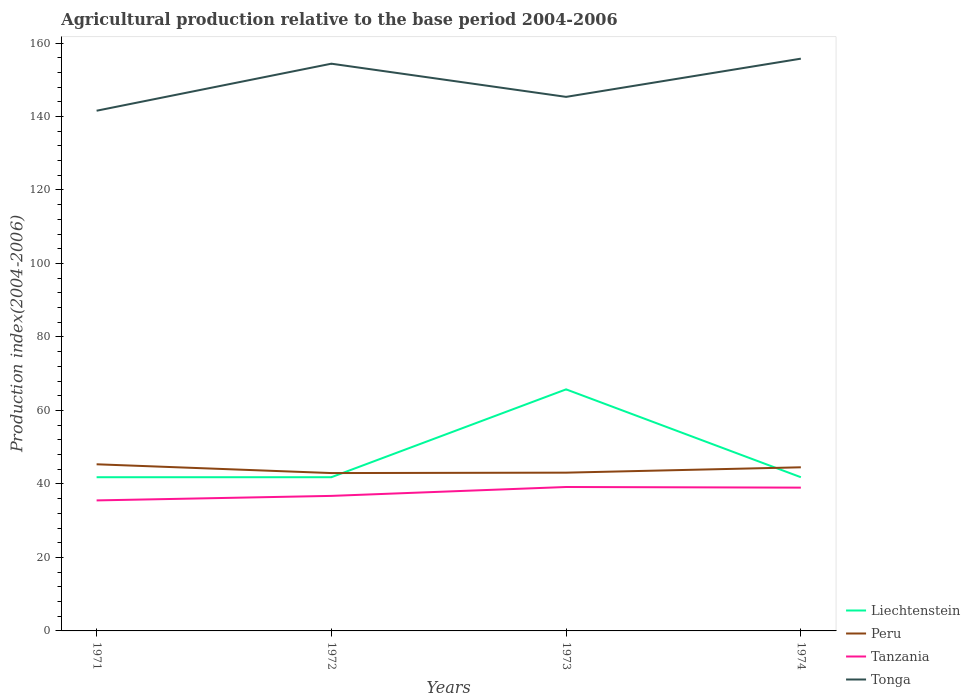How many different coloured lines are there?
Offer a terse response. 4. Does the line corresponding to Tanzania intersect with the line corresponding to Liechtenstein?
Offer a very short reply. No. Is the number of lines equal to the number of legend labels?
Make the answer very short. Yes. Across all years, what is the maximum agricultural production index in Liechtenstein?
Provide a short and direct response. 41.83. What is the total agricultural production index in Peru in the graph?
Make the answer very short. 2.39. What is the difference between the highest and the second highest agricultural production index in Tanzania?
Offer a terse response. 3.65. How many lines are there?
Provide a succinct answer. 4. What is the difference between two consecutive major ticks on the Y-axis?
Provide a succinct answer. 20. Are the values on the major ticks of Y-axis written in scientific E-notation?
Offer a very short reply. No. Does the graph contain any zero values?
Offer a very short reply. No. How are the legend labels stacked?
Keep it short and to the point. Vertical. What is the title of the graph?
Your response must be concise. Agricultural production relative to the base period 2004-2006. Does "Seychelles" appear as one of the legend labels in the graph?
Offer a very short reply. No. What is the label or title of the Y-axis?
Keep it short and to the point. Production index(2004-2006). What is the Production index(2004-2006) of Liechtenstein in 1971?
Your response must be concise. 41.83. What is the Production index(2004-2006) in Peru in 1971?
Offer a terse response. 45.35. What is the Production index(2004-2006) of Tanzania in 1971?
Ensure brevity in your answer.  35.52. What is the Production index(2004-2006) in Tonga in 1971?
Give a very brief answer. 141.57. What is the Production index(2004-2006) of Liechtenstein in 1972?
Make the answer very short. 41.83. What is the Production index(2004-2006) in Peru in 1972?
Your answer should be compact. 42.96. What is the Production index(2004-2006) of Tanzania in 1972?
Keep it short and to the point. 36.75. What is the Production index(2004-2006) of Tonga in 1972?
Your response must be concise. 154.37. What is the Production index(2004-2006) in Liechtenstein in 1973?
Your answer should be very brief. 65.74. What is the Production index(2004-2006) of Peru in 1973?
Make the answer very short. 43.07. What is the Production index(2004-2006) of Tanzania in 1973?
Make the answer very short. 39.17. What is the Production index(2004-2006) of Tonga in 1973?
Your answer should be very brief. 145.34. What is the Production index(2004-2006) in Liechtenstein in 1974?
Offer a terse response. 41.83. What is the Production index(2004-2006) of Peru in 1974?
Give a very brief answer. 44.53. What is the Production index(2004-2006) of Tonga in 1974?
Your response must be concise. 155.74. Across all years, what is the maximum Production index(2004-2006) in Liechtenstein?
Your answer should be compact. 65.74. Across all years, what is the maximum Production index(2004-2006) of Peru?
Provide a short and direct response. 45.35. Across all years, what is the maximum Production index(2004-2006) of Tanzania?
Provide a short and direct response. 39.17. Across all years, what is the maximum Production index(2004-2006) of Tonga?
Your answer should be compact. 155.74. Across all years, what is the minimum Production index(2004-2006) of Liechtenstein?
Make the answer very short. 41.83. Across all years, what is the minimum Production index(2004-2006) of Peru?
Offer a very short reply. 42.96. Across all years, what is the minimum Production index(2004-2006) in Tanzania?
Offer a very short reply. 35.52. Across all years, what is the minimum Production index(2004-2006) of Tonga?
Keep it short and to the point. 141.57. What is the total Production index(2004-2006) in Liechtenstein in the graph?
Your answer should be very brief. 191.23. What is the total Production index(2004-2006) in Peru in the graph?
Provide a succinct answer. 175.91. What is the total Production index(2004-2006) of Tanzania in the graph?
Provide a succinct answer. 150.44. What is the total Production index(2004-2006) of Tonga in the graph?
Give a very brief answer. 597.02. What is the difference between the Production index(2004-2006) in Peru in 1971 and that in 1972?
Your answer should be very brief. 2.39. What is the difference between the Production index(2004-2006) of Tanzania in 1971 and that in 1972?
Your answer should be compact. -1.23. What is the difference between the Production index(2004-2006) of Liechtenstein in 1971 and that in 1973?
Provide a short and direct response. -23.91. What is the difference between the Production index(2004-2006) of Peru in 1971 and that in 1973?
Your answer should be compact. 2.28. What is the difference between the Production index(2004-2006) of Tanzania in 1971 and that in 1973?
Keep it short and to the point. -3.65. What is the difference between the Production index(2004-2006) of Tonga in 1971 and that in 1973?
Your answer should be compact. -3.77. What is the difference between the Production index(2004-2006) of Peru in 1971 and that in 1974?
Provide a short and direct response. 0.82. What is the difference between the Production index(2004-2006) in Tanzania in 1971 and that in 1974?
Provide a short and direct response. -3.48. What is the difference between the Production index(2004-2006) in Tonga in 1971 and that in 1974?
Offer a terse response. -14.17. What is the difference between the Production index(2004-2006) in Liechtenstein in 1972 and that in 1973?
Provide a succinct answer. -23.91. What is the difference between the Production index(2004-2006) of Peru in 1972 and that in 1973?
Make the answer very short. -0.11. What is the difference between the Production index(2004-2006) of Tanzania in 1972 and that in 1973?
Keep it short and to the point. -2.42. What is the difference between the Production index(2004-2006) in Tonga in 1972 and that in 1973?
Your answer should be very brief. 9.03. What is the difference between the Production index(2004-2006) in Liechtenstein in 1972 and that in 1974?
Keep it short and to the point. 0. What is the difference between the Production index(2004-2006) in Peru in 1972 and that in 1974?
Offer a terse response. -1.57. What is the difference between the Production index(2004-2006) in Tanzania in 1972 and that in 1974?
Ensure brevity in your answer.  -2.25. What is the difference between the Production index(2004-2006) of Tonga in 1972 and that in 1974?
Provide a succinct answer. -1.37. What is the difference between the Production index(2004-2006) of Liechtenstein in 1973 and that in 1974?
Offer a terse response. 23.91. What is the difference between the Production index(2004-2006) of Peru in 1973 and that in 1974?
Provide a succinct answer. -1.46. What is the difference between the Production index(2004-2006) of Tanzania in 1973 and that in 1974?
Your response must be concise. 0.17. What is the difference between the Production index(2004-2006) in Liechtenstein in 1971 and the Production index(2004-2006) in Peru in 1972?
Give a very brief answer. -1.13. What is the difference between the Production index(2004-2006) in Liechtenstein in 1971 and the Production index(2004-2006) in Tanzania in 1972?
Provide a succinct answer. 5.08. What is the difference between the Production index(2004-2006) of Liechtenstein in 1971 and the Production index(2004-2006) of Tonga in 1972?
Your response must be concise. -112.54. What is the difference between the Production index(2004-2006) in Peru in 1971 and the Production index(2004-2006) in Tanzania in 1972?
Your response must be concise. 8.6. What is the difference between the Production index(2004-2006) in Peru in 1971 and the Production index(2004-2006) in Tonga in 1972?
Your response must be concise. -109.02. What is the difference between the Production index(2004-2006) of Tanzania in 1971 and the Production index(2004-2006) of Tonga in 1972?
Keep it short and to the point. -118.85. What is the difference between the Production index(2004-2006) of Liechtenstein in 1971 and the Production index(2004-2006) of Peru in 1973?
Your response must be concise. -1.24. What is the difference between the Production index(2004-2006) in Liechtenstein in 1971 and the Production index(2004-2006) in Tanzania in 1973?
Provide a succinct answer. 2.66. What is the difference between the Production index(2004-2006) of Liechtenstein in 1971 and the Production index(2004-2006) of Tonga in 1973?
Your answer should be very brief. -103.51. What is the difference between the Production index(2004-2006) of Peru in 1971 and the Production index(2004-2006) of Tanzania in 1973?
Your answer should be compact. 6.18. What is the difference between the Production index(2004-2006) in Peru in 1971 and the Production index(2004-2006) in Tonga in 1973?
Your answer should be very brief. -99.99. What is the difference between the Production index(2004-2006) of Tanzania in 1971 and the Production index(2004-2006) of Tonga in 1973?
Offer a terse response. -109.82. What is the difference between the Production index(2004-2006) in Liechtenstein in 1971 and the Production index(2004-2006) in Tanzania in 1974?
Your answer should be very brief. 2.83. What is the difference between the Production index(2004-2006) in Liechtenstein in 1971 and the Production index(2004-2006) in Tonga in 1974?
Offer a very short reply. -113.91. What is the difference between the Production index(2004-2006) of Peru in 1971 and the Production index(2004-2006) of Tanzania in 1974?
Provide a short and direct response. 6.35. What is the difference between the Production index(2004-2006) of Peru in 1971 and the Production index(2004-2006) of Tonga in 1974?
Make the answer very short. -110.39. What is the difference between the Production index(2004-2006) in Tanzania in 1971 and the Production index(2004-2006) in Tonga in 1974?
Make the answer very short. -120.22. What is the difference between the Production index(2004-2006) of Liechtenstein in 1972 and the Production index(2004-2006) of Peru in 1973?
Offer a very short reply. -1.24. What is the difference between the Production index(2004-2006) in Liechtenstein in 1972 and the Production index(2004-2006) in Tanzania in 1973?
Give a very brief answer. 2.66. What is the difference between the Production index(2004-2006) in Liechtenstein in 1972 and the Production index(2004-2006) in Tonga in 1973?
Ensure brevity in your answer.  -103.51. What is the difference between the Production index(2004-2006) in Peru in 1972 and the Production index(2004-2006) in Tanzania in 1973?
Give a very brief answer. 3.79. What is the difference between the Production index(2004-2006) in Peru in 1972 and the Production index(2004-2006) in Tonga in 1973?
Keep it short and to the point. -102.38. What is the difference between the Production index(2004-2006) of Tanzania in 1972 and the Production index(2004-2006) of Tonga in 1973?
Provide a short and direct response. -108.59. What is the difference between the Production index(2004-2006) of Liechtenstein in 1972 and the Production index(2004-2006) of Tanzania in 1974?
Keep it short and to the point. 2.83. What is the difference between the Production index(2004-2006) of Liechtenstein in 1972 and the Production index(2004-2006) of Tonga in 1974?
Provide a succinct answer. -113.91. What is the difference between the Production index(2004-2006) of Peru in 1972 and the Production index(2004-2006) of Tanzania in 1974?
Your answer should be very brief. 3.96. What is the difference between the Production index(2004-2006) in Peru in 1972 and the Production index(2004-2006) in Tonga in 1974?
Provide a short and direct response. -112.78. What is the difference between the Production index(2004-2006) of Tanzania in 1972 and the Production index(2004-2006) of Tonga in 1974?
Make the answer very short. -118.99. What is the difference between the Production index(2004-2006) in Liechtenstein in 1973 and the Production index(2004-2006) in Peru in 1974?
Offer a very short reply. 21.21. What is the difference between the Production index(2004-2006) of Liechtenstein in 1973 and the Production index(2004-2006) of Tanzania in 1974?
Your answer should be compact. 26.74. What is the difference between the Production index(2004-2006) of Liechtenstein in 1973 and the Production index(2004-2006) of Tonga in 1974?
Your answer should be compact. -90. What is the difference between the Production index(2004-2006) in Peru in 1973 and the Production index(2004-2006) in Tanzania in 1974?
Offer a very short reply. 4.07. What is the difference between the Production index(2004-2006) of Peru in 1973 and the Production index(2004-2006) of Tonga in 1974?
Keep it short and to the point. -112.67. What is the difference between the Production index(2004-2006) of Tanzania in 1973 and the Production index(2004-2006) of Tonga in 1974?
Provide a short and direct response. -116.57. What is the average Production index(2004-2006) of Liechtenstein per year?
Give a very brief answer. 47.81. What is the average Production index(2004-2006) in Peru per year?
Provide a succinct answer. 43.98. What is the average Production index(2004-2006) in Tanzania per year?
Your answer should be compact. 37.61. What is the average Production index(2004-2006) of Tonga per year?
Your response must be concise. 149.25. In the year 1971, what is the difference between the Production index(2004-2006) of Liechtenstein and Production index(2004-2006) of Peru?
Give a very brief answer. -3.52. In the year 1971, what is the difference between the Production index(2004-2006) in Liechtenstein and Production index(2004-2006) in Tanzania?
Offer a terse response. 6.31. In the year 1971, what is the difference between the Production index(2004-2006) of Liechtenstein and Production index(2004-2006) of Tonga?
Offer a very short reply. -99.74. In the year 1971, what is the difference between the Production index(2004-2006) in Peru and Production index(2004-2006) in Tanzania?
Offer a terse response. 9.83. In the year 1971, what is the difference between the Production index(2004-2006) in Peru and Production index(2004-2006) in Tonga?
Offer a terse response. -96.22. In the year 1971, what is the difference between the Production index(2004-2006) of Tanzania and Production index(2004-2006) of Tonga?
Provide a short and direct response. -106.05. In the year 1972, what is the difference between the Production index(2004-2006) in Liechtenstein and Production index(2004-2006) in Peru?
Your answer should be compact. -1.13. In the year 1972, what is the difference between the Production index(2004-2006) in Liechtenstein and Production index(2004-2006) in Tanzania?
Give a very brief answer. 5.08. In the year 1972, what is the difference between the Production index(2004-2006) in Liechtenstein and Production index(2004-2006) in Tonga?
Ensure brevity in your answer.  -112.54. In the year 1972, what is the difference between the Production index(2004-2006) in Peru and Production index(2004-2006) in Tanzania?
Ensure brevity in your answer.  6.21. In the year 1972, what is the difference between the Production index(2004-2006) of Peru and Production index(2004-2006) of Tonga?
Give a very brief answer. -111.41. In the year 1972, what is the difference between the Production index(2004-2006) in Tanzania and Production index(2004-2006) in Tonga?
Keep it short and to the point. -117.62. In the year 1973, what is the difference between the Production index(2004-2006) in Liechtenstein and Production index(2004-2006) in Peru?
Provide a short and direct response. 22.67. In the year 1973, what is the difference between the Production index(2004-2006) of Liechtenstein and Production index(2004-2006) of Tanzania?
Offer a very short reply. 26.57. In the year 1973, what is the difference between the Production index(2004-2006) of Liechtenstein and Production index(2004-2006) of Tonga?
Provide a succinct answer. -79.6. In the year 1973, what is the difference between the Production index(2004-2006) in Peru and Production index(2004-2006) in Tanzania?
Offer a very short reply. 3.9. In the year 1973, what is the difference between the Production index(2004-2006) in Peru and Production index(2004-2006) in Tonga?
Your response must be concise. -102.27. In the year 1973, what is the difference between the Production index(2004-2006) in Tanzania and Production index(2004-2006) in Tonga?
Provide a short and direct response. -106.17. In the year 1974, what is the difference between the Production index(2004-2006) in Liechtenstein and Production index(2004-2006) in Peru?
Your answer should be compact. -2.7. In the year 1974, what is the difference between the Production index(2004-2006) of Liechtenstein and Production index(2004-2006) of Tanzania?
Your answer should be very brief. 2.83. In the year 1974, what is the difference between the Production index(2004-2006) of Liechtenstein and Production index(2004-2006) of Tonga?
Offer a terse response. -113.91. In the year 1974, what is the difference between the Production index(2004-2006) in Peru and Production index(2004-2006) in Tanzania?
Your response must be concise. 5.53. In the year 1974, what is the difference between the Production index(2004-2006) in Peru and Production index(2004-2006) in Tonga?
Your answer should be very brief. -111.21. In the year 1974, what is the difference between the Production index(2004-2006) in Tanzania and Production index(2004-2006) in Tonga?
Your answer should be compact. -116.74. What is the ratio of the Production index(2004-2006) of Liechtenstein in 1971 to that in 1972?
Offer a very short reply. 1. What is the ratio of the Production index(2004-2006) of Peru in 1971 to that in 1972?
Provide a succinct answer. 1.06. What is the ratio of the Production index(2004-2006) of Tanzania in 1971 to that in 1972?
Provide a short and direct response. 0.97. What is the ratio of the Production index(2004-2006) of Tonga in 1971 to that in 1972?
Offer a very short reply. 0.92. What is the ratio of the Production index(2004-2006) of Liechtenstein in 1971 to that in 1973?
Offer a terse response. 0.64. What is the ratio of the Production index(2004-2006) of Peru in 1971 to that in 1973?
Offer a very short reply. 1.05. What is the ratio of the Production index(2004-2006) in Tanzania in 1971 to that in 1973?
Provide a short and direct response. 0.91. What is the ratio of the Production index(2004-2006) of Tonga in 1971 to that in 1973?
Keep it short and to the point. 0.97. What is the ratio of the Production index(2004-2006) in Peru in 1971 to that in 1974?
Give a very brief answer. 1.02. What is the ratio of the Production index(2004-2006) of Tanzania in 1971 to that in 1974?
Keep it short and to the point. 0.91. What is the ratio of the Production index(2004-2006) in Tonga in 1971 to that in 1974?
Offer a very short reply. 0.91. What is the ratio of the Production index(2004-2006) of Liechtenstein in 1972 to that in 1973?
Keep it short and to the point. 0.64. What is the ratio of the Production index(2004-2006) in Peru in 1972 to that in 1973?
Give a very brief answer. 1. What is the ratio of the Production index(2004-2006) in Tanzania in 1972 to that in 1973?
Give a very brief answer. 0.94. What is the ratio of the Production index(2004-2006) of Tonga in 1972 to that in 1973?
Ensure brevity in your answer.  1.06. What is the ratio of the Production index(2004-2006) in Peru in 1972 to that in 1974?
Your answer should be compact. 0.96. What is the ratio of the Production index(2004-2006) in Tanzania in 1972 to that in 1974?
Your answer should be compact. 0.94. What is the ratio of the Production index(2004-2006) of Liechtenstein in 1973 to that in 1974?
Your answer should be very brief. 1.57. What is the ratio of the Production index(2004-2006) of Peru in 1973 to that in 1974?
Make the answer very short. 0.97. What is the ratio of the Production index(2004-2006) of Tanzania in 1973 to that in 1974?
Your response must be concise. 1. What is the ratio of the Production index(2004-2006) in Tonga in 1973 to that in 1974?
Your response must be concise. 0.93. What is the difference between the highest and the second highest Production index(2004-2006) in Liechtenstein?
Ensure brevity in your answer.  23.91. What is the difference between the highest and the second highest Production index(2004-2006) of Peru?
Offer a very short reply. 0.82. What is the difference between the highest and the second highest Production index(2004-2006) of Tanzania?
Your answer should be very brief. 0.17. What is the difference between the highest and the second highest Production index(2004-2006) in Tonga?
Provide a succinct answer. 1.37. What is the difference between the highest and the lowest Production index(2004-2006) of Liechtenstein?
Provide a short and direct response. 23.91. What is the difference between the highest and the lowest Production index(2004-2006) of Peru?
Provide a succinct answer. 2.39. What is the difference between the highest and the lowest Production index(2004-2006) in Tanzania?
Provide a succinct answer. 3.65. What is the difference between the highest and the lowest Production index(2004-2006) in Tonga?
Your answer should be very brief. 14.17. 